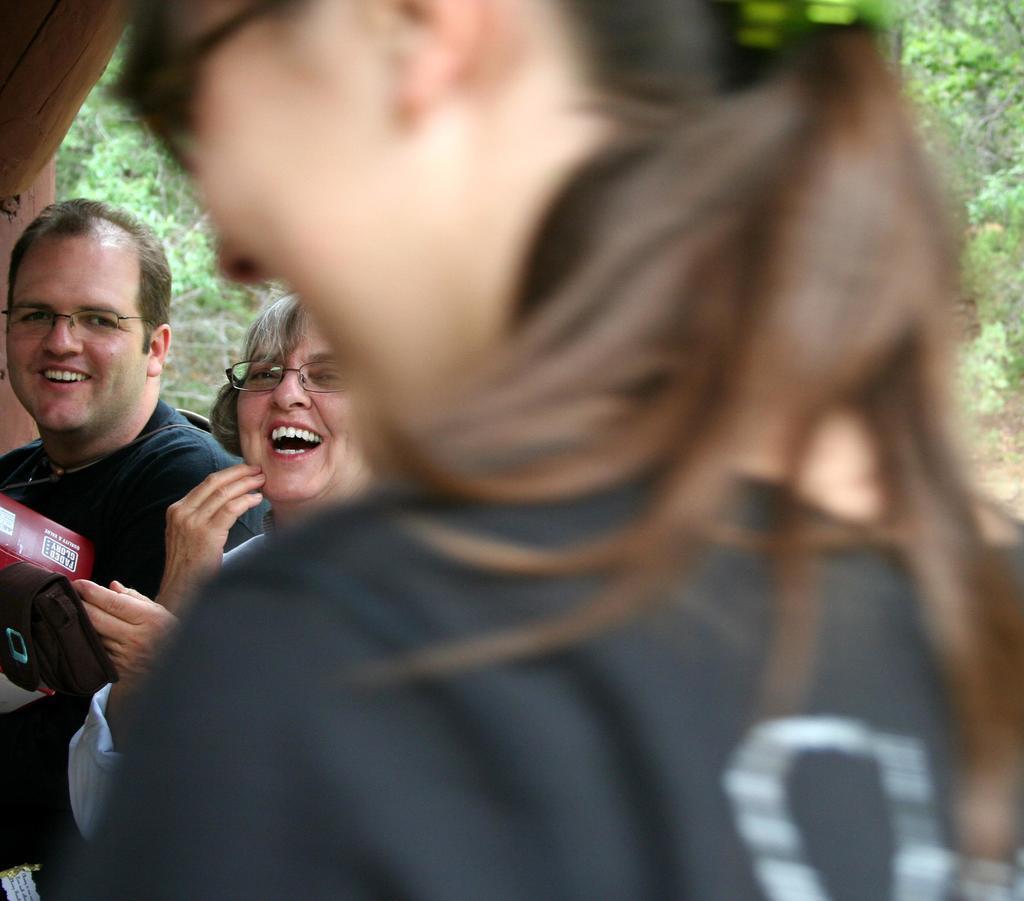Could you give a brief overview of what you see in this image? In this image there are three people. They all are smiling. 